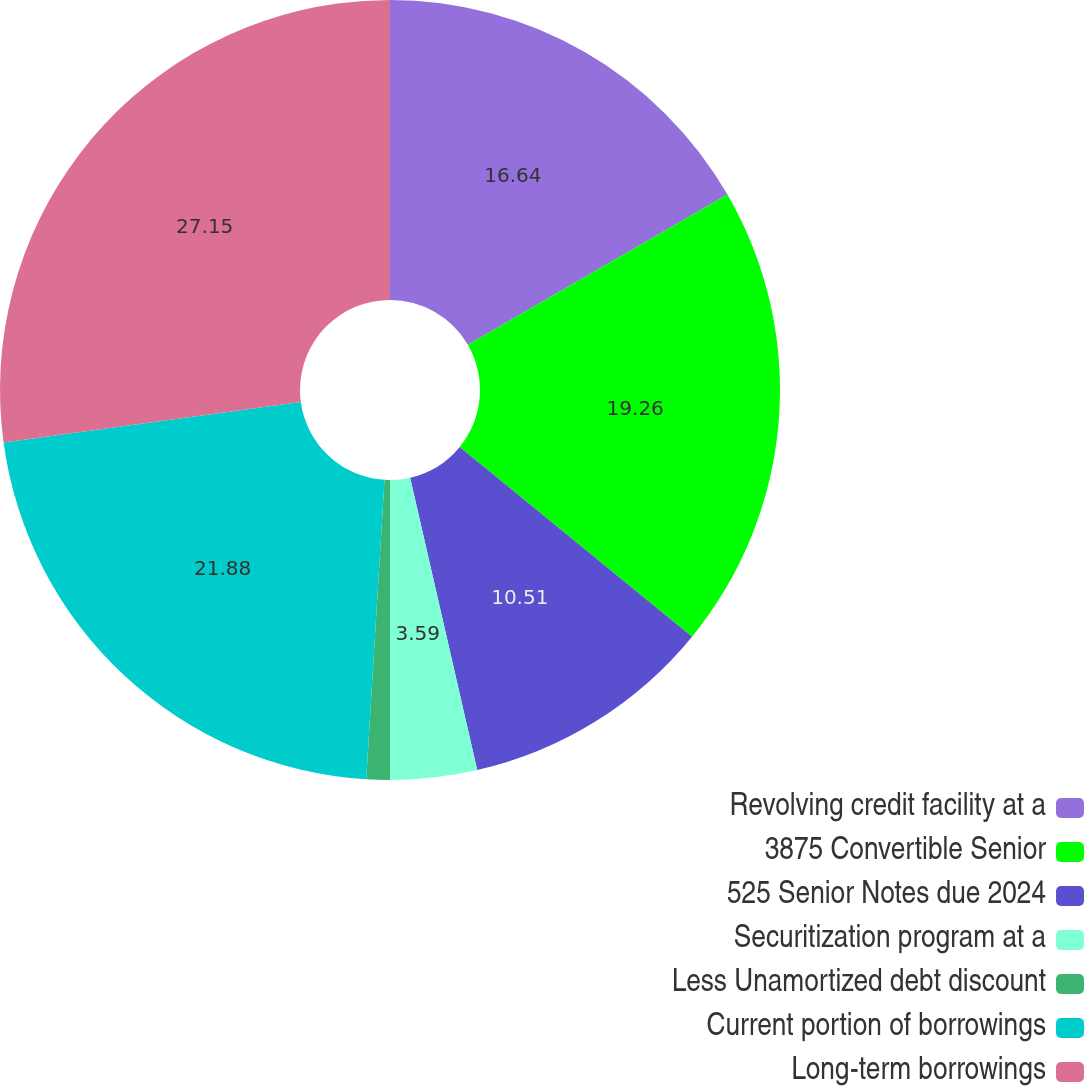<chart> <loc_0><loc_0><loc_500><loc_500><pie_chart><fcel>Revolving credit facility at a<fcel>3875 Convertible Senior<fcel>525 Senior Notes due 2024<fcel>Securitization program at a<fcel>Less Unamortized debt discount<fcel>Current portion of borrowings<fcel>Long-term borrowings<nl><fcel>16.64%<fcel>19.26%<fcel>10.51%<fcel>3.59%<fcel>0.97%<fcel>21.88%<fcel>27.15%<nl></chart> 